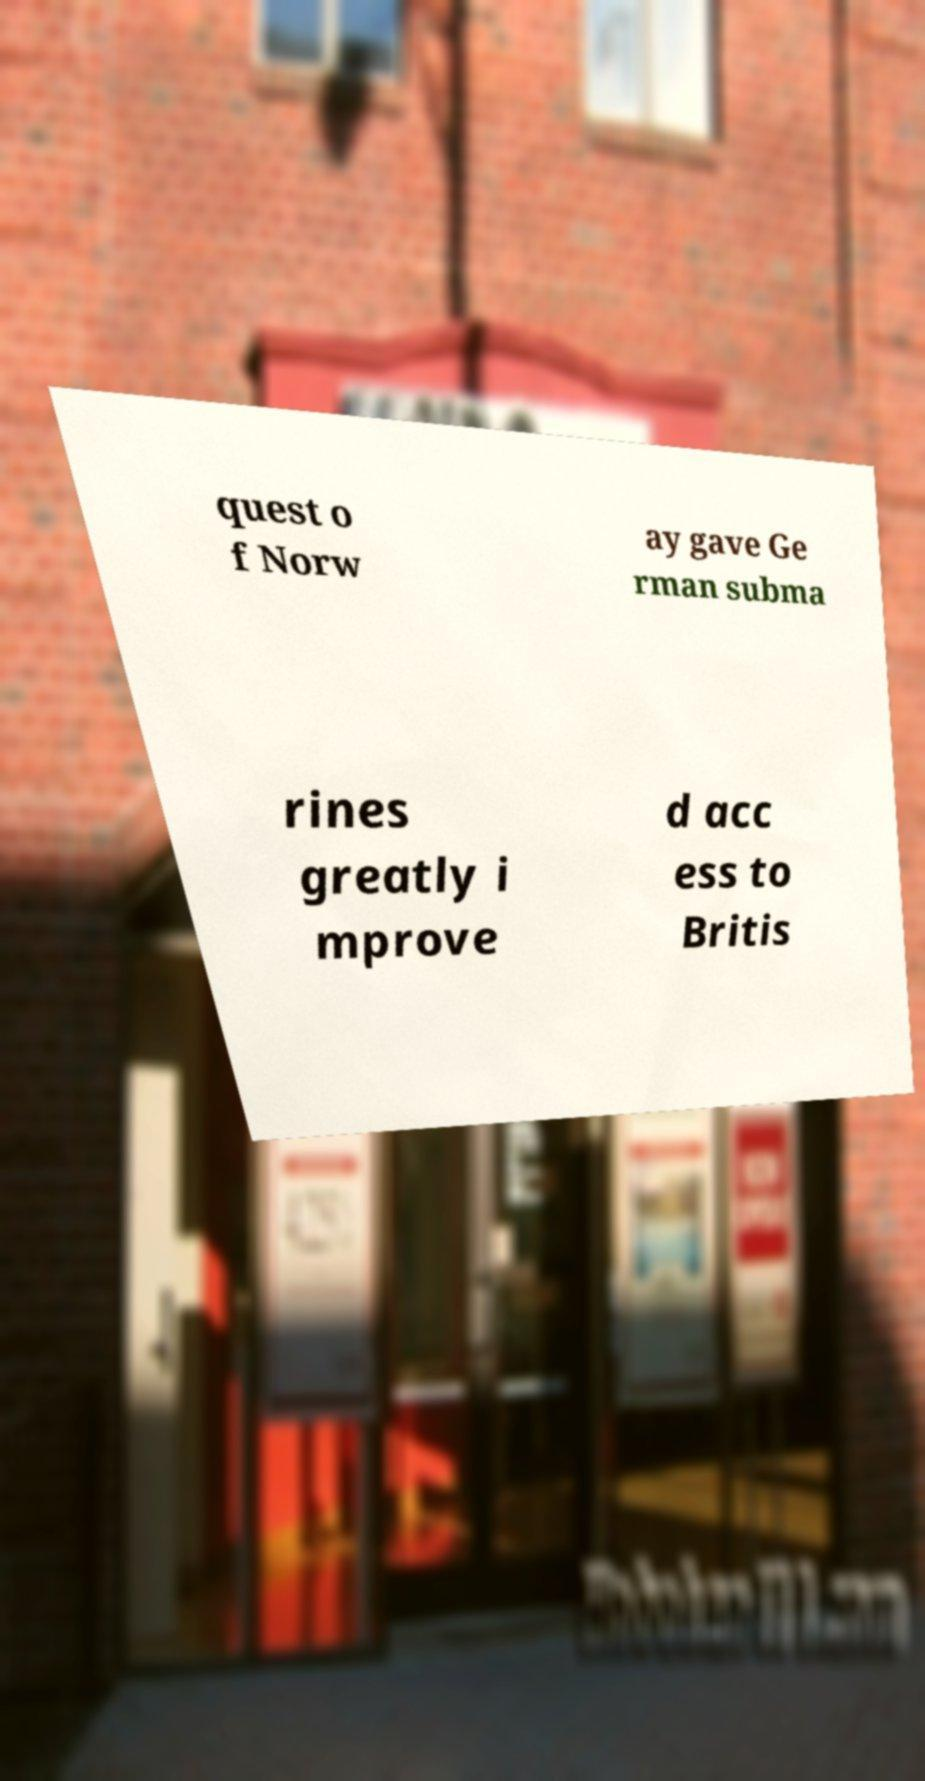I need the written content from this picture converted into text. Can you do that? quest o f Norw ay gave Ge rman subma rines greatly i mprove d acc ess to Britis 